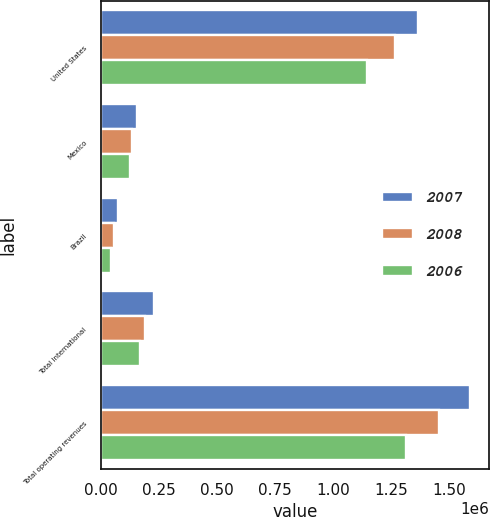Convert chart. <chart><loc_0><loc_0><loc_500><loc_500><stacked_bar_chart><ecel><fcel>United States<fcel>Mexico<fcel>Brazil<fcel>Total International<fcel>Total operating revenues<nl><fcel>2007<fcel>1.36668e+06<fcel>155321<fcel>71001<fcel>226819<fcel>1.5935e+06<nl><fcel>2008<fcel>1.26832e+06<fcel>134800<fcel>53478<fcel>188278<fcel>1.45659e+06<nl><fcel>2006<fcel>1.14779e+06<fcel>125694<fcel>43904<fcel>169598<fcel>1.31738e+06<nl></chart> 